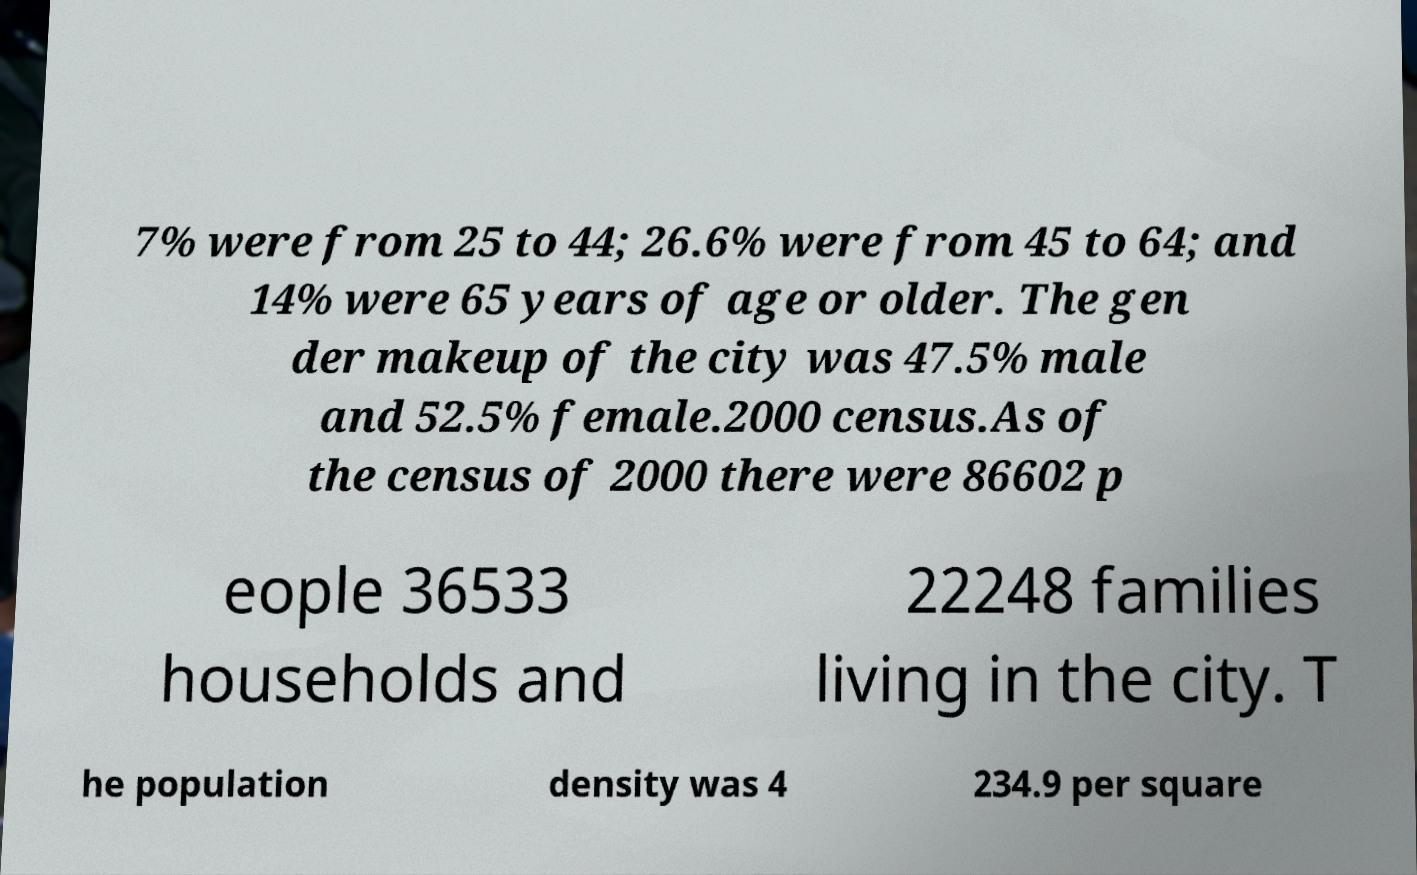There's text embedded in this image that I need extracted. Can you transcribe it verbatim? 7% were from 25 to 44; 26.6% were from 45 to 64; and 14% were 65 years of age or older. The gen der makeup of the city was 47.5% male and 52.5% female.2000 census.As of the census of 2000 there were 86602 p eople 36533 households and 22248 families living in the city. T he population density was 4 234.9 per square 